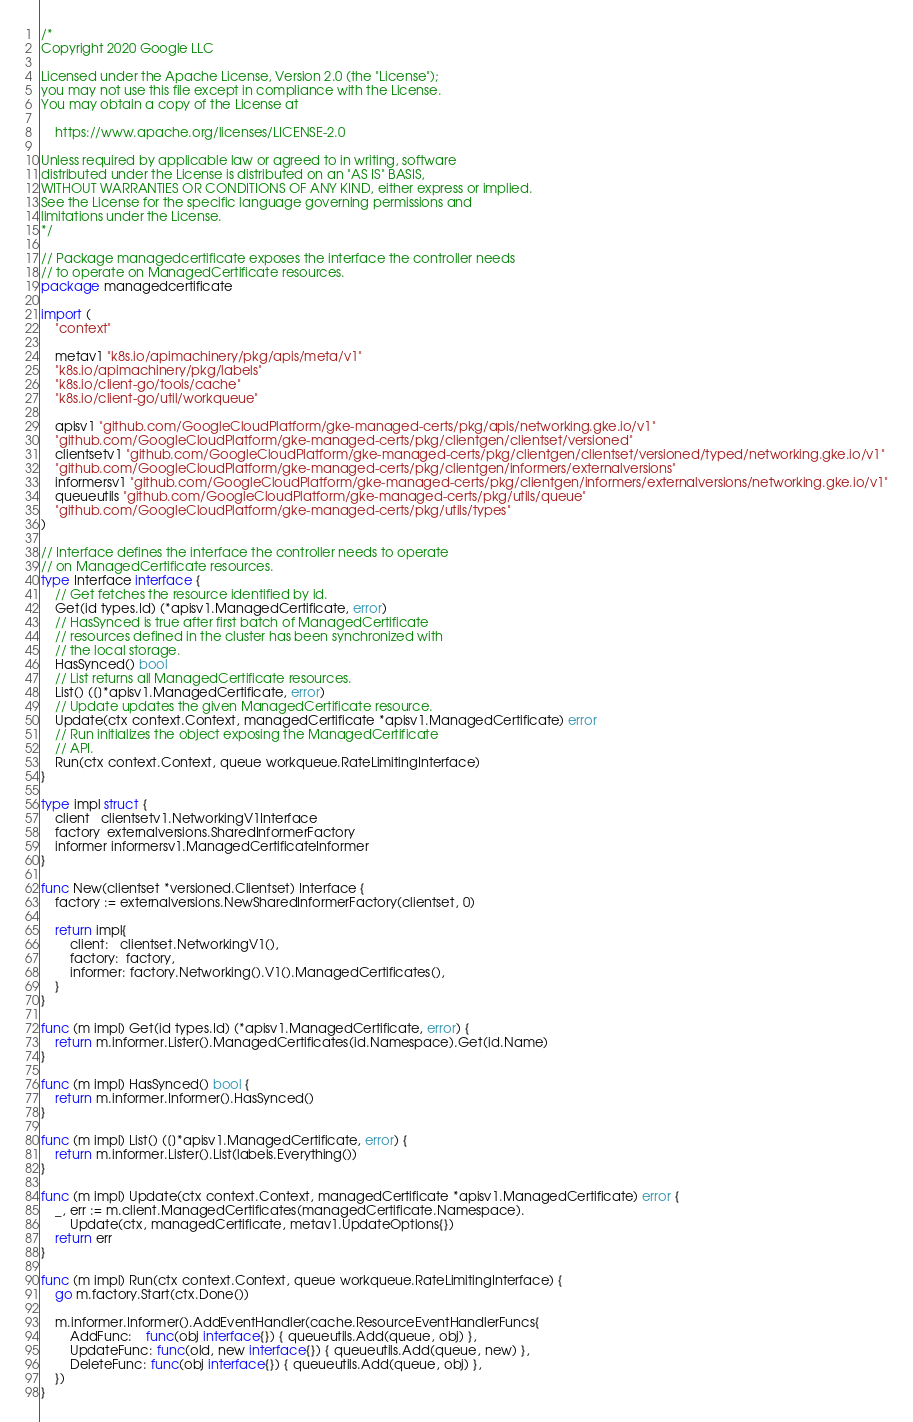<code> <loc_0><loc_0><loc_500><loc_500><_Go_>/*
Copyright 2020 Google LLC

Licensed under the Apache License, Version 2.0 (the "License");
you may not use this file except in compliance with the License.
You may obtain a copy of the License at

    https://www.apache.org/licenses/LICENSE-2.0

Unless required by applicable law or agreed to in writing, software
distributed under the License is distributed on an "AS IS" BASIS,
WITHOUT WARRANTIES OR CONDITIONS OF ANY KIND, either express or implied.
See the License for the specific language governing permissions and
limitations under the License.
*/

// Package managedcertificate exposes the interface the controller needs
// to operate on ManagedCertificate resources.
package managedcertificate

import (
	"context"

	metav1 "k8s.io/apimachinery/pkg/apis/meta/v1"
	"k8s.io/apimachinery/pkg/labels"
	"k8s.io/client-go/tools/cache"
	"k8s.io/client-go/util/workqueue"

	apisv1 "github.com/GoogleCloudPlatform/gke-managed-certs/pkg/apis/networking.gke.io/v1"
	"github.com/GoogleCloudPlatform/gke-managed-certs/pkg/clientgen/clientset/versioned"
	clientsetv1 "github.com/GoogleCloudPlatform/gke-managed-certs/pkg/clientgen/clientset/versioned/typed/networking.gke.io/v1"
	"github.com/GoogleCloudPlatform/gke-managed-certs/pkg/clientgen/informers/externalversions"
	informersv1 "github.com/GoogleCloudPlatform/gke-managed-certs/pkg/clientgen/informers/externalversions/networking.gke.io/v1"
	queueutils "github.com/GoogleCloudPlatform/gke-managed-certs/pkg/utils/queue"
	"github.com/GoogleCloudPlatform/gke-managed-certs/pkg/utils/types"
)

// Interface defines the interface the controller needs to operate
// on ManagedCertificate resources.
type Interface interface {
	// Get fetches the resource identified by id.
	Get(id types.Id) (*apisv1.ManagedCertificate, error)
	// HasSynced is true after first batch of ManagedCertificate
	// resources defined in the cluster has been synchronized with
	// the local storage.
	HasSynced() bool
	// List returns all ManagedCertificate resources.
	List() ([]*apisv1.ManagedCertificate, error)
	// Update updates the given ManagedCertificate resource.
	Update(ctx context.Context, managedCertificate *apisv1.ManagedCertificate) error
	// Run initializes the object exposing the ManagedCertificate
	// API.
	Run(ctx context.Context, queue workqueue.RateLimitingInterface)
}

type impl struct {
	client   clientsetv1.NetworkingV1Interface
	factory  externalversions.SharedInformerFactory
	informer informersv1.ManagedCertificateInformer
}

func New(clientset *versioned.Clientset) Interface {
	factory := externalversions.NewSharedInformerFactory(clientset, 0)

	return impl{
		client:   clientset.NetworkingV1(),
		factory:  factory,
		informer: factory.Networking().V1().ManagedCertificates(),
	}
}

func (m impl) Get(id types.Id) (*apisv1.ManagedCertificate, error) {
	return m.informer.Lister().ManagedCertificates(id.Namespace).Get(id.Name)
}

func (m impl) HasSynced() bool {
	return m.informer.Informer().HasSynced()
}

func (m impl) List() ([]*apisv1.ManagedCertificate, error) {
	return m.informer.Lister().List(labels.Everything())
}

func (m impl) Update(ctx context.Context, managedCertificate *apisv1.ManagedCertificate) error {
	_, err := m.client.ManagedCertificates(managedCertificate.Namespace).
		Update(ctx, managedCertificate, metav1.UpdateOptions{})
	return err
}

func (m impl) Run(ctx context.Context, queue workqueue.RateLimitingInterface) {
	go m.factory.Start(ctx.Done())

	m.informer.Informer().AddEventHandler(cache.ResourceEventHandlerFuncs{
		AddFunc:    func(obj interface{}) { queueutils.Add(queue, obj) },
		UpdateFunc: func(old, new interface{}) { queueutils.Add(queue, new) },
		DeleteFunc: func(obj interface{}) { queueutils.Add(queue, obj) },
	})
}
</code> 